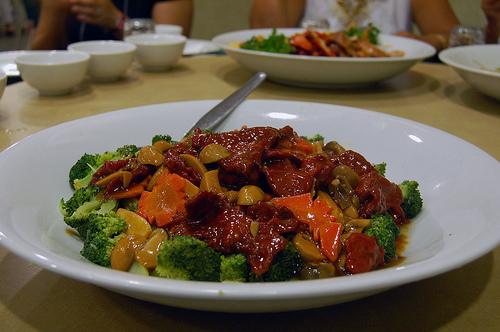Are there vegetables on the plate?
Be succinct. Yes. How many forks are on the plate?
Short answer required. 1. What is on the plate?
Write a very short answer. Chinese food. What utensils are shown here?
Give a very brief answer. Fork. How many utensils do you see?
Keep it brief. 1. What kind of sauce was used for this dish?
Concise answer only. Soy. They appear old?
Keep it brief. No. Does this look like a buffet?
Short answer required. No. 